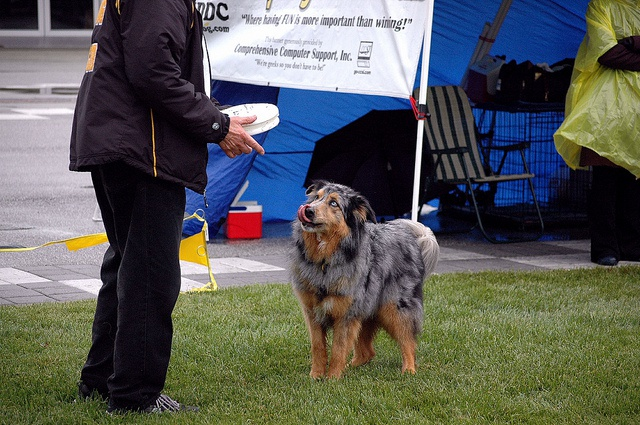Describe the objects in this image and their specific colors. I can see people in black and gray tones, dog in black, gray, and maroon tones, people in black and olive tones, chair in black, gray, navy, and darkblue tones, and umbrella in black, navy, darkblue, and blue tones in this image. 